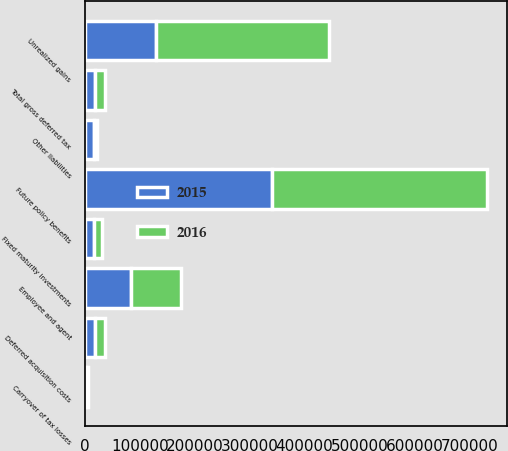Convert chart to OTSL. <chart><loc_0><loc_0><loc_500><loc_500><stacked_bar_chart><ecel><fcel>Fixed maturity investments<fcel>Carryover of tax losses<fcel>Total gross deferred tax<fcel>Unrealized gains<fcel>Employee and agent<fcel>Deferred acquisition costs<fcel>Future policy benefits<fcel>Other liabilities<nl><fcel>2016<fcel>15004<fcel>3906<fcel>18910<fcel>315509<fcel>92131<fcel>18637<fcel>391451<fcel>3987<nl><fcel>2015<fcel>16098<fcel>2266<fcel>18364<fcel>128683<fcel>83229<fcel>18637<fcel>340854<fcel>17176<nl></chart> 